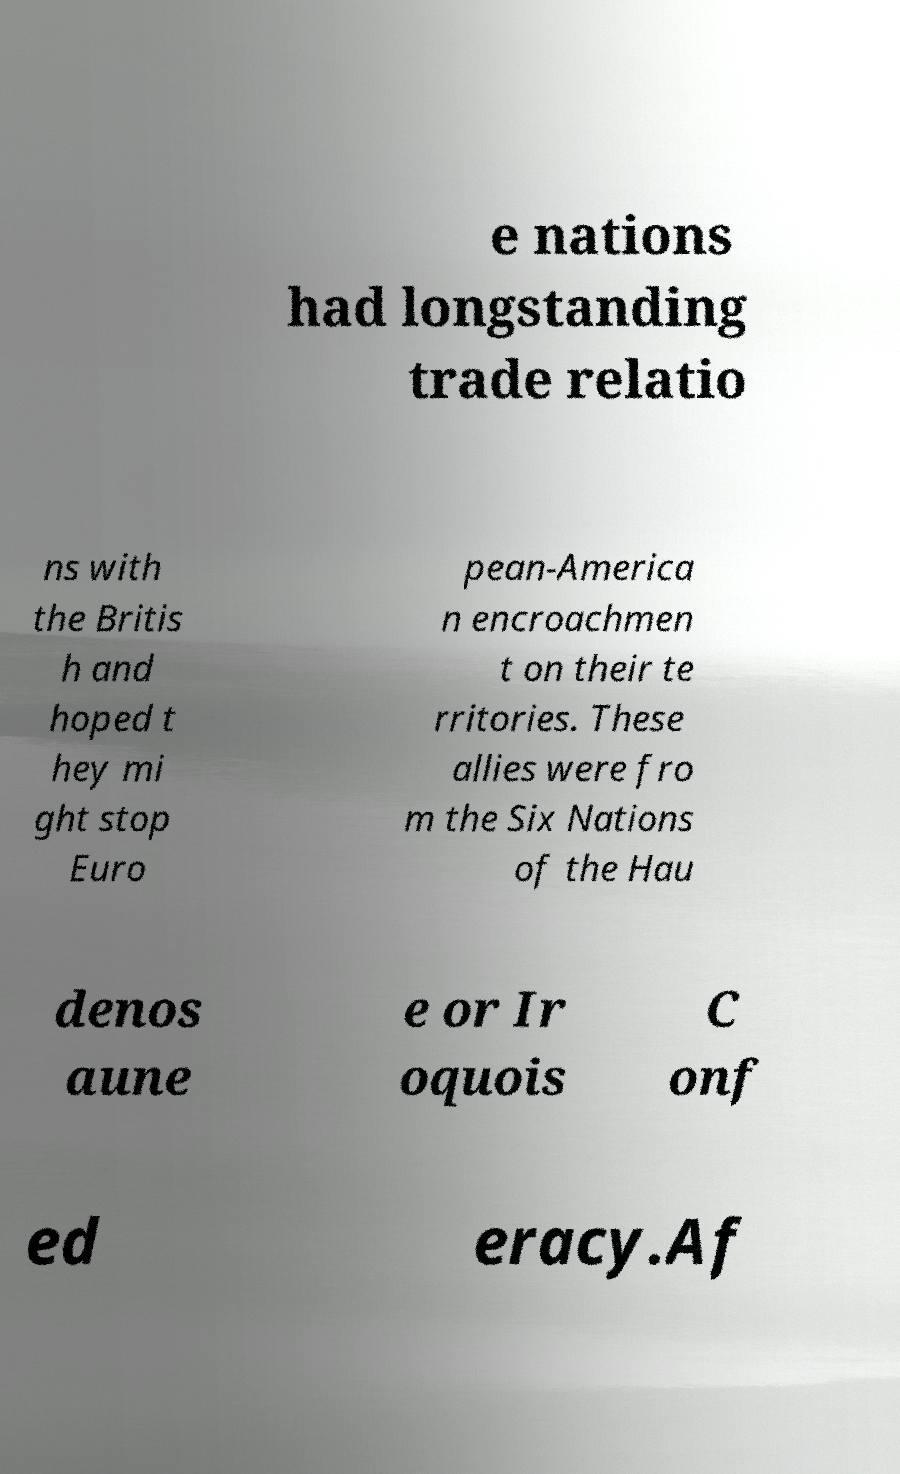Could you extract and type out the text from this image? e nations had longstanding trade relatio ns with the Britis h and hoped t hey mi ght stop Euro pean-America n encroachmen t on their te rritories. These allies were fro m the Six Nations of the Hau denos aune e or Ir oquois C onf ed eracy.Af 